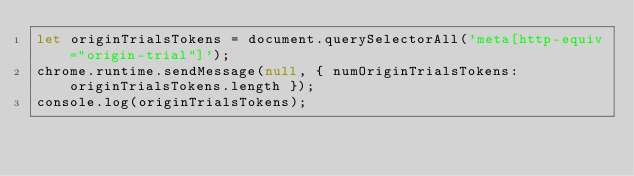<code> <loc_0><loc_0><loc_500><loc_500><_JavaScript_>let originTrialsTokens = document.querySelectorAll('meta[http-equiv="origin-trial"]');
chrome.runtime.sendMessage(null, { numOriginTrialsTokens: originTrialsTokens.length });
console.log(originTrialsTokens);
  </code> 